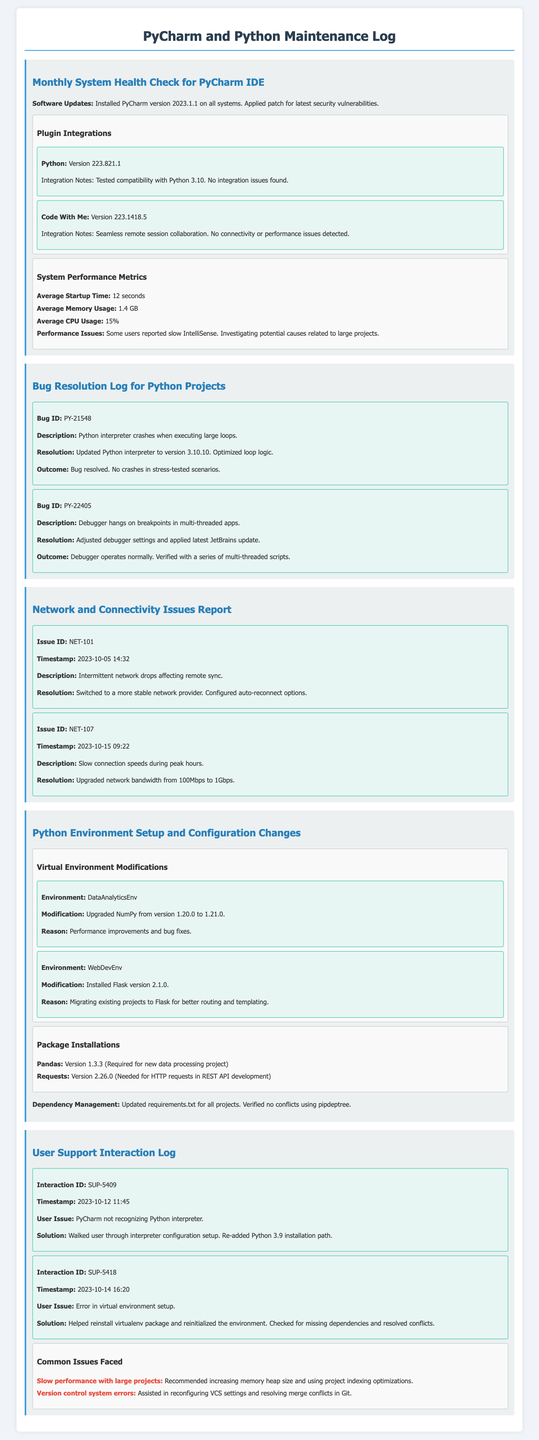What is the installed PyCharm version? The installed PyCharm version can be found in the software updates section.
Answer: 2023.1.1 What was the bug ID for the Python interpreter crash? The bug ID related to the Python interpreter crash is mentioned in the Bug Resolution Log.
Answer: PY-21548 What average memory usage is reported? The average memory usage is listed under system performance metrics.
Answer: 1.4 GB When was the network issue with intermittent drops reported? The timestamp for the network issue can be found in the network issues report.
Answer: 2023-10-05 14:32 What changes were made to the DataAnalyticsEnv? The modification to the DataAnalyticsEnv is specified under Python Environment Setup.
Answer: Upgraded NumPy from version 1.20.0 to 1.21.0 What was the resolution for the slow connection during peak hours? The resolution for the slow connection is documented in the network issues report.
Answer: Upgraded network bandwidth from 100Mbps to 1Gbps What is a common issue faced by users related to large projects? The common issue is outlined in the user support interaction log.
Answer: Slow performance with large projects Which plugin was tested for compatibility with Python 3.10? The plugin compatibility can be found in the plugin integrations section.
Answer: Python How was the virtual environment setup error resolved? The resolution for the virtual environment setup error is explained in the user support interaction log.
Answer: Helped reinstall virtualenv package and reinitialized the environment 